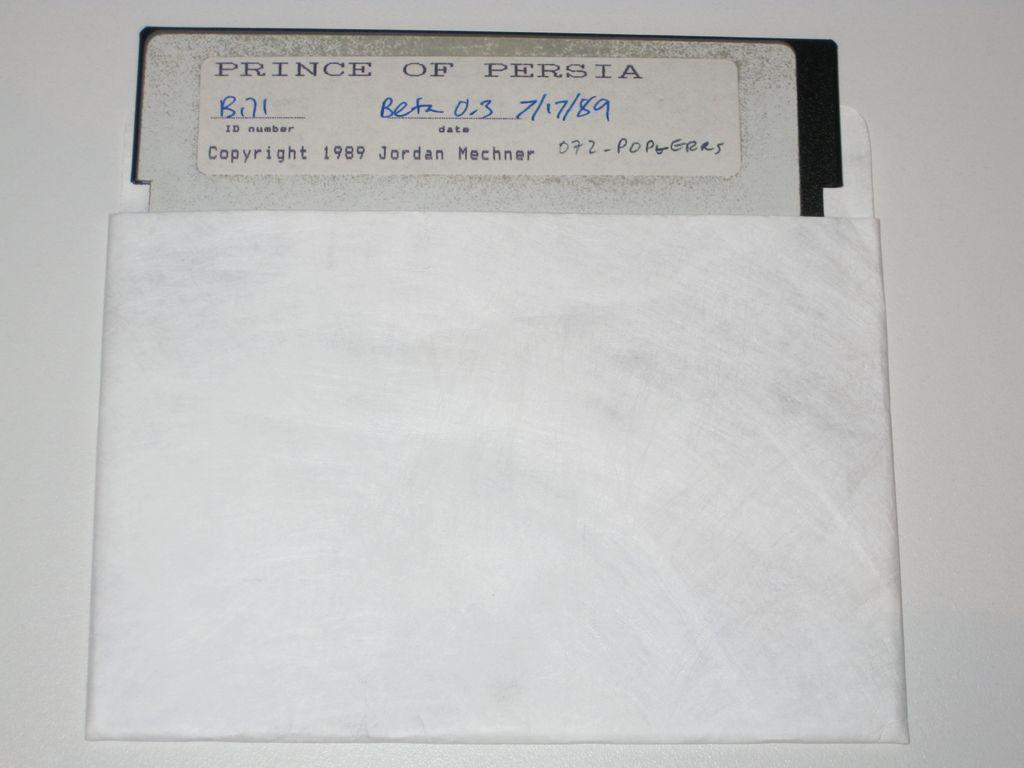<image>
Share a concise interpretation of the image provided. A white paper reading price of persia that has been copy righted and dated. 